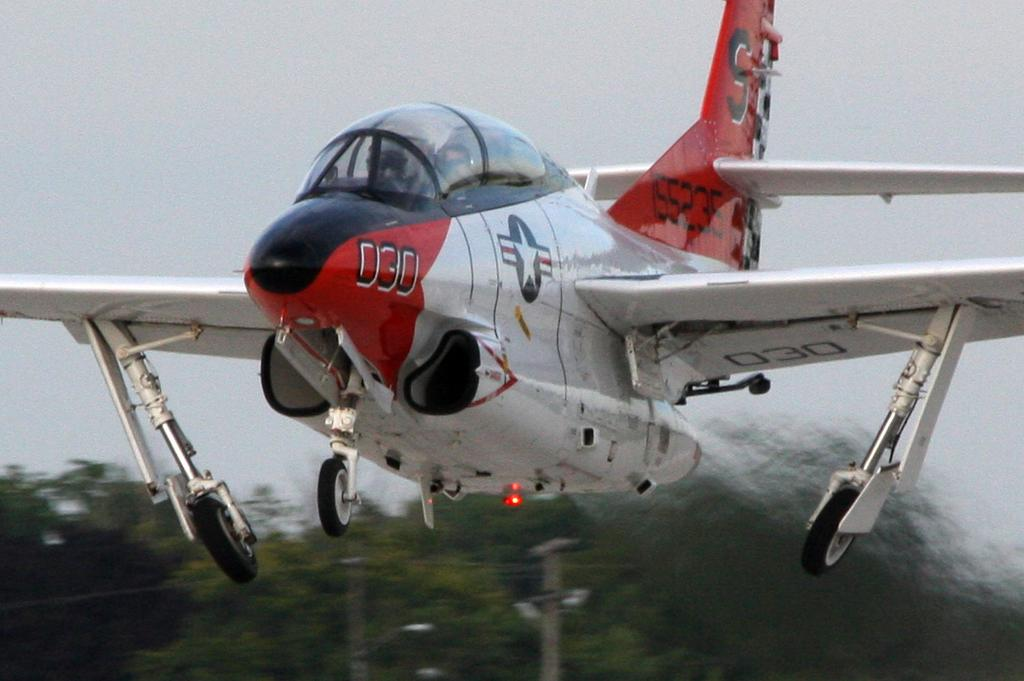<image>
Give a short and clear explanation of the subsequent image. The jet plane has the number 030 on the front of it 